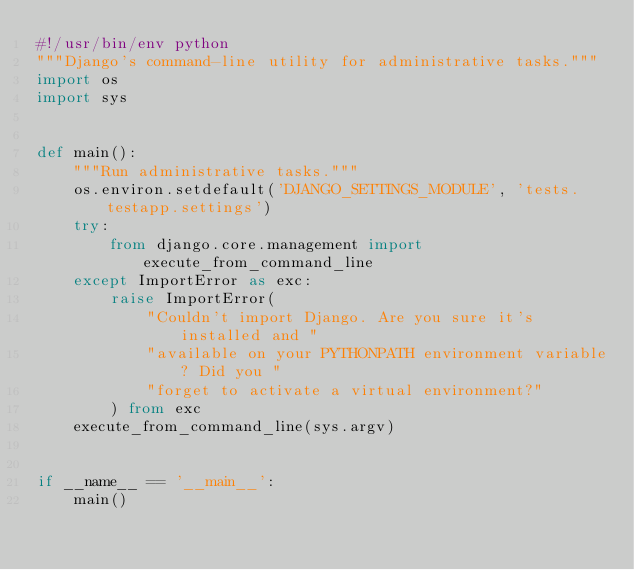<code> <loc_0><loc_0><loc_500><loc_500><_Python_>#!/usr/bin/env python
"""Django's command-line utility for administrative tasks."""
import os
import sys


def main():
    """Run administrative tasks."""
    os.environ.setdefault('DJANGO_SETTINGS_MODULE', 'tests.testapp.settings')
    try:
        from django.core.management import execute_from_command_line
    except ImportError as exc:
        raise ImportError(
            "Couldn't import Django. Are you sure it's installed and "
            "available on your PYTHONPATH environment variable? Did you "
            "forget to activate a virtual environment?"
        ) from exc
    execute_from_command_line(sys.argv)


if __name__ == '__main__':
    main()

</code> 